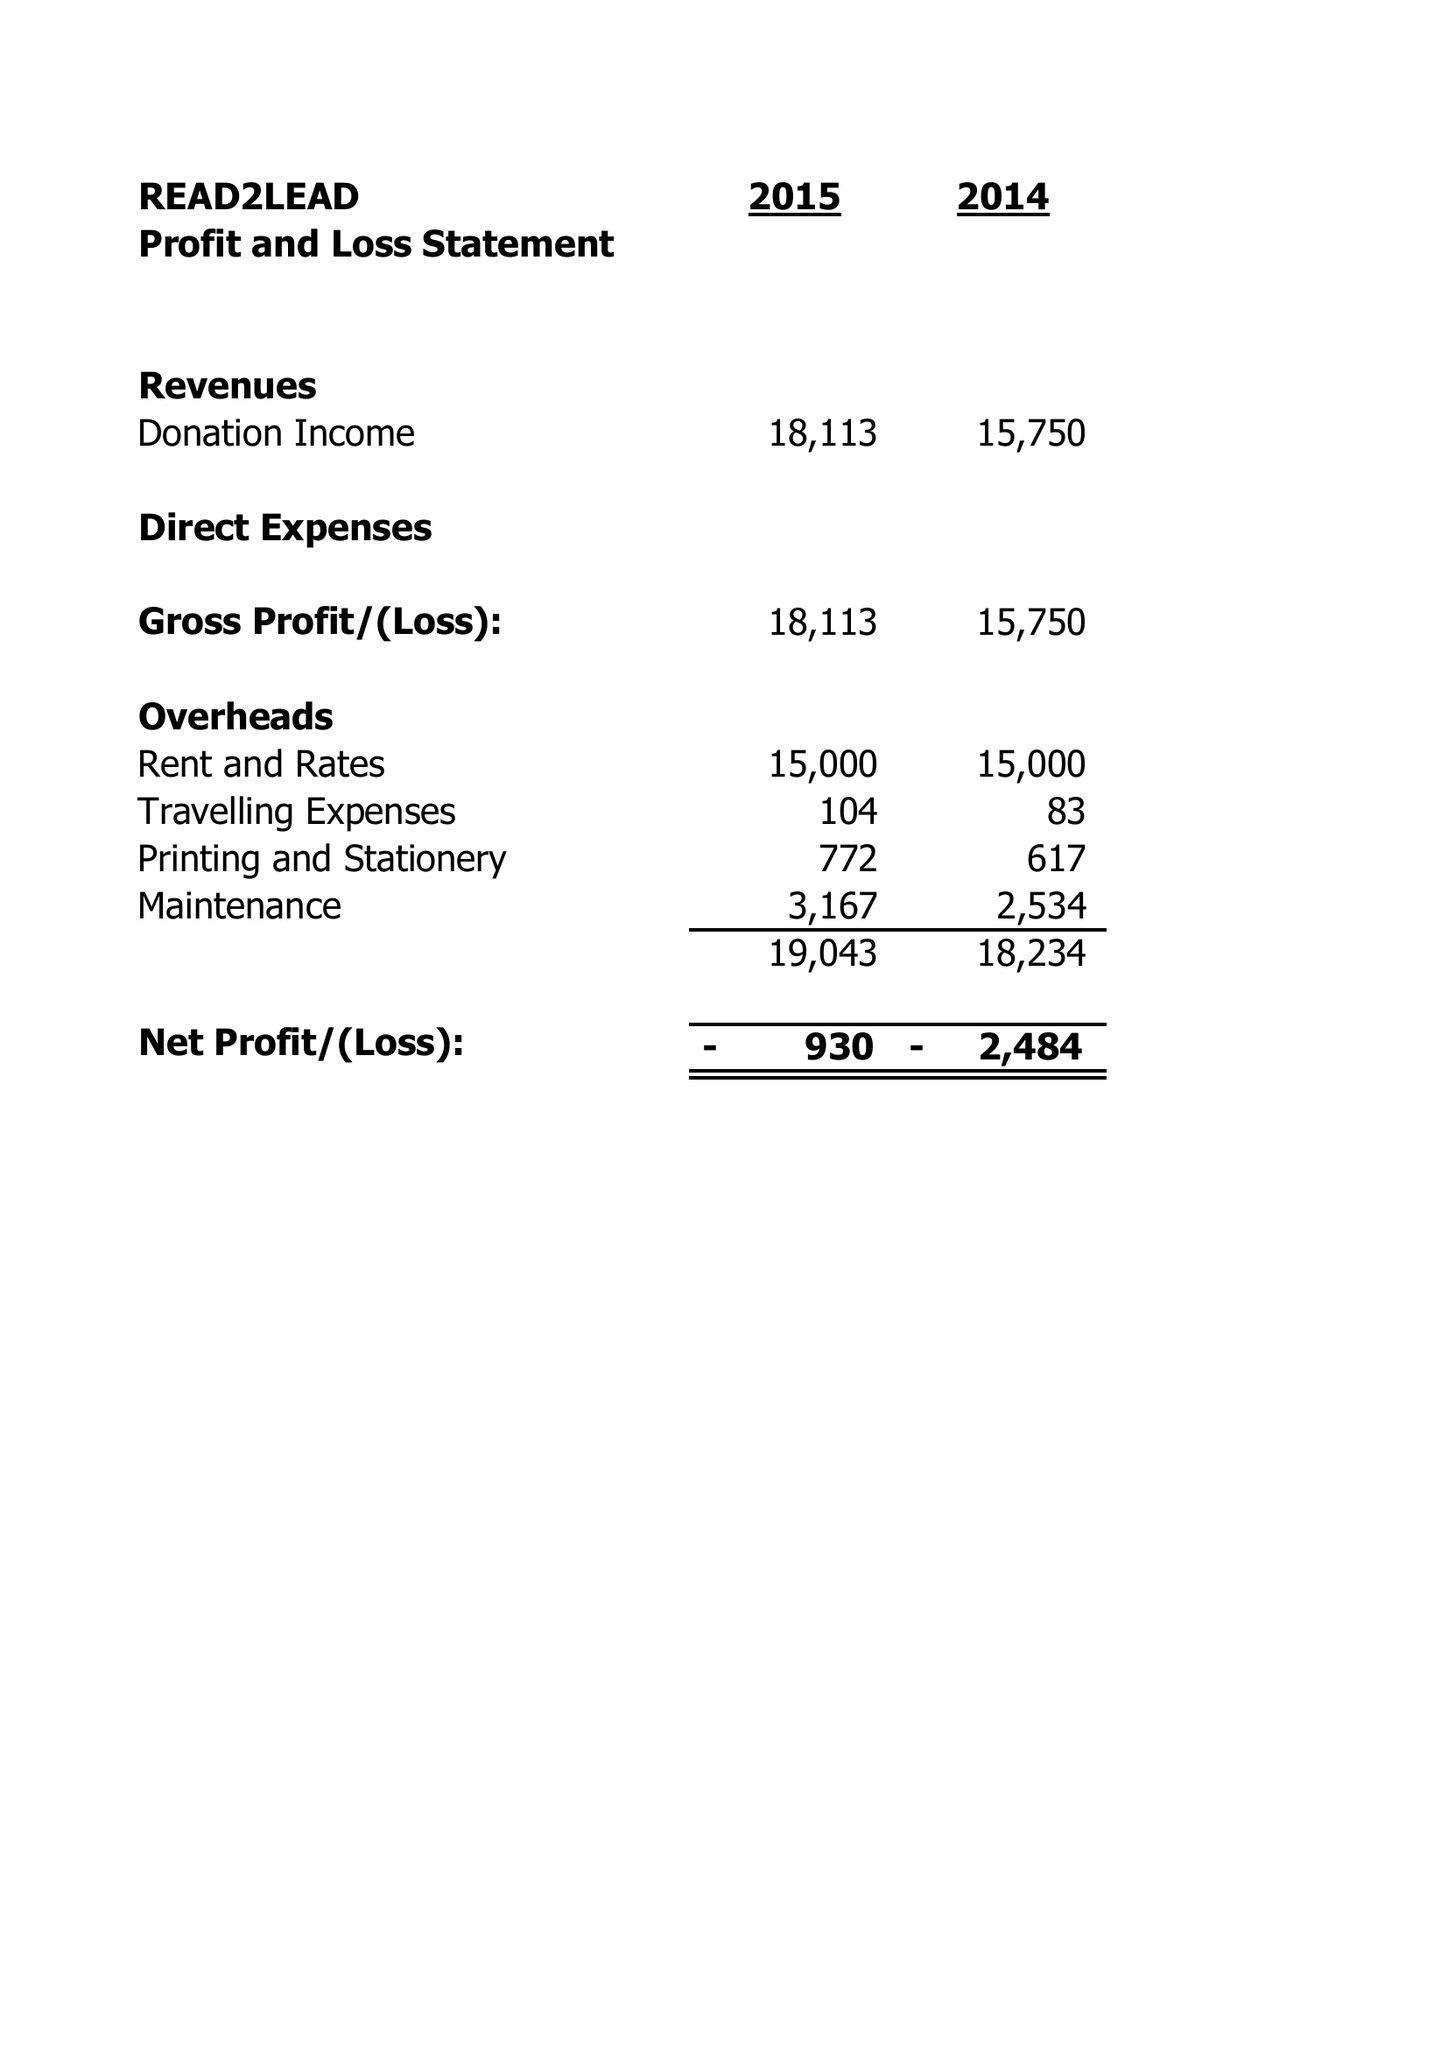What is the value for the spending_annually_in_british_pounds?
Answer the question using a single word or phrase. 24950.00 